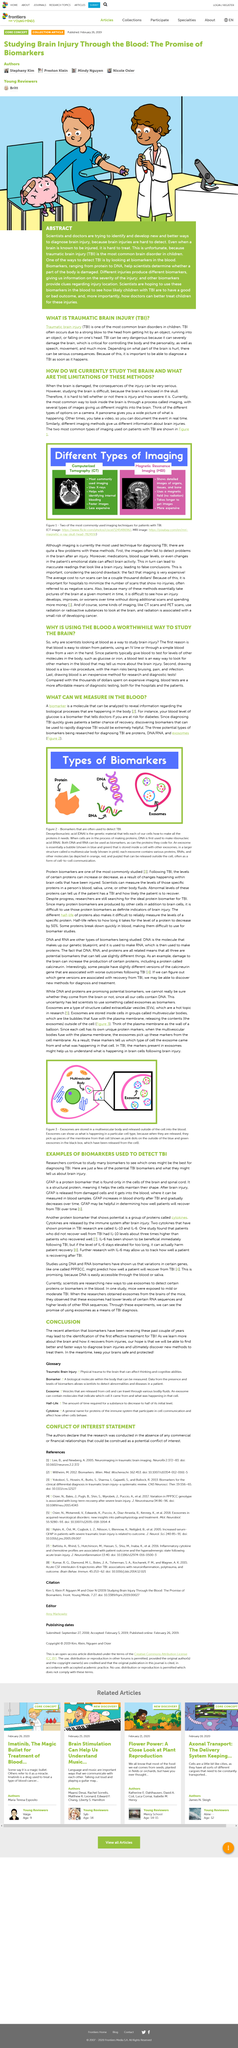Specify some key components in this picture. Yes, DNA, RNA, and proteins are all related. Exosomes are stored in multivesicular bodies, which are specialized structures within cells that facilitate the transport and release of these small vesicles. The most commonly used types of imaging in patients with traumatic brain injury are Computerized Tomography and Magnetic Resonance Imaging. A biomarker is a molecule that can be analyzed to reveal information regarding the biological processes occurring in the body, as stated. Computerized Tomography is the least expensive of the imaging methods. 